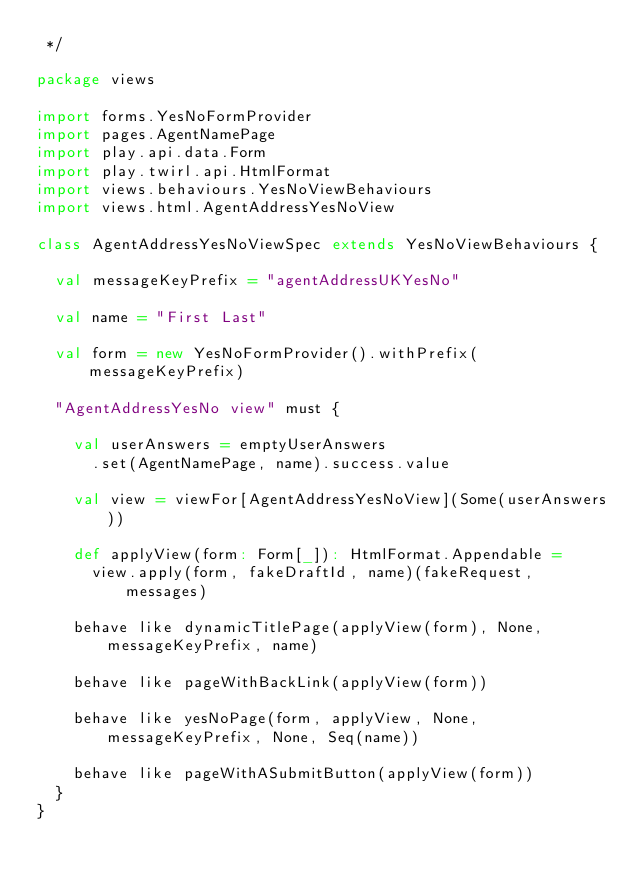<code> <loc_0><loc_0><loc_500><loc_500><_Scala_> */

package views

import forms.YesNoFormProvider
import pages.AgentNamePage
import play.api.data.Form
import play.twirl.api.HtmlFormat
import views.behaviours.YesNoViewBehaviours
import views.html.AgentAddressYesNoView

class AgentAddressYesNoViewSpec extends YesNoViewBehaviours {

  val messageKeyPrefix = "agentAddressUKYesNo"

  val name = "First Last"

  val form = new YesNoFormProvider().withPrefix(messageKeyPrefix)

  "AgentAddressYesNo view" must {

    val userAnswers = emptyUserAnswers
      .set(AgentNamePage, name).success.value

    val view = viewFor[AgentAddressYesNoView](Some(userAnswers))

    def applyView(form: Form[_]): HtmlFormat.Appendable =
      view.apply(form, fakeDraftId, name)(fakeRequest, messages)

    behave like dynamicTitlePage(applyView(form), None, messageKeyPrefix, name)

    behave like pageWithBackLink(applyView(form))

    behave like yesNoPage(form, applyView, None, messageKeyPrefix, None, Seq(name))

    behave like pageWithASubmitButton(applyView(form))
  }
}
</code> 